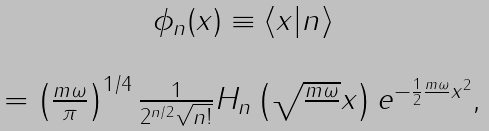<formula> <loc_0><loc_0><loc_500><loc_500>\begin{array} { c } \phi _ { n } ( x ) \equiv \langle x | n \rangle \\ \\ = \left ( \frac { m \omega } { \pi } \right ) ^ { 1 / 4 } \frac { 1 } { 2 ^ { n / 2 } \sqrt { n ! } } H _ { n } \left ( \sqrt { \frac { m \omega } { } } x \right ) e ^ { - \frac { 1 } { 2 } \frac { m \omega } { } x ^ { 2 } } , \end{array}</formula> 